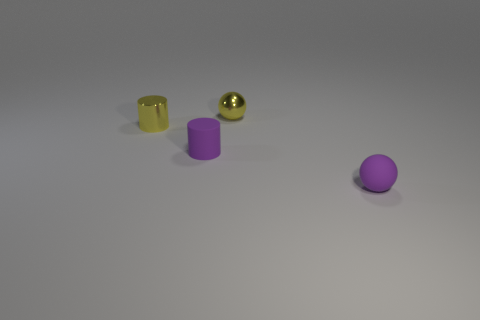Add 3 tiny purple matte balls. How many objects exist? 7 Subtract 0 gray cylinders. How many objects are left? 4 Subtract all small rubber spheres. Subtract all green metal things. How many objects are left? 3 Add 2 tiny purple objects. How many tiny purple objects are left? 4 Add 3 small green blocks. How many small green blocks exist? 3 